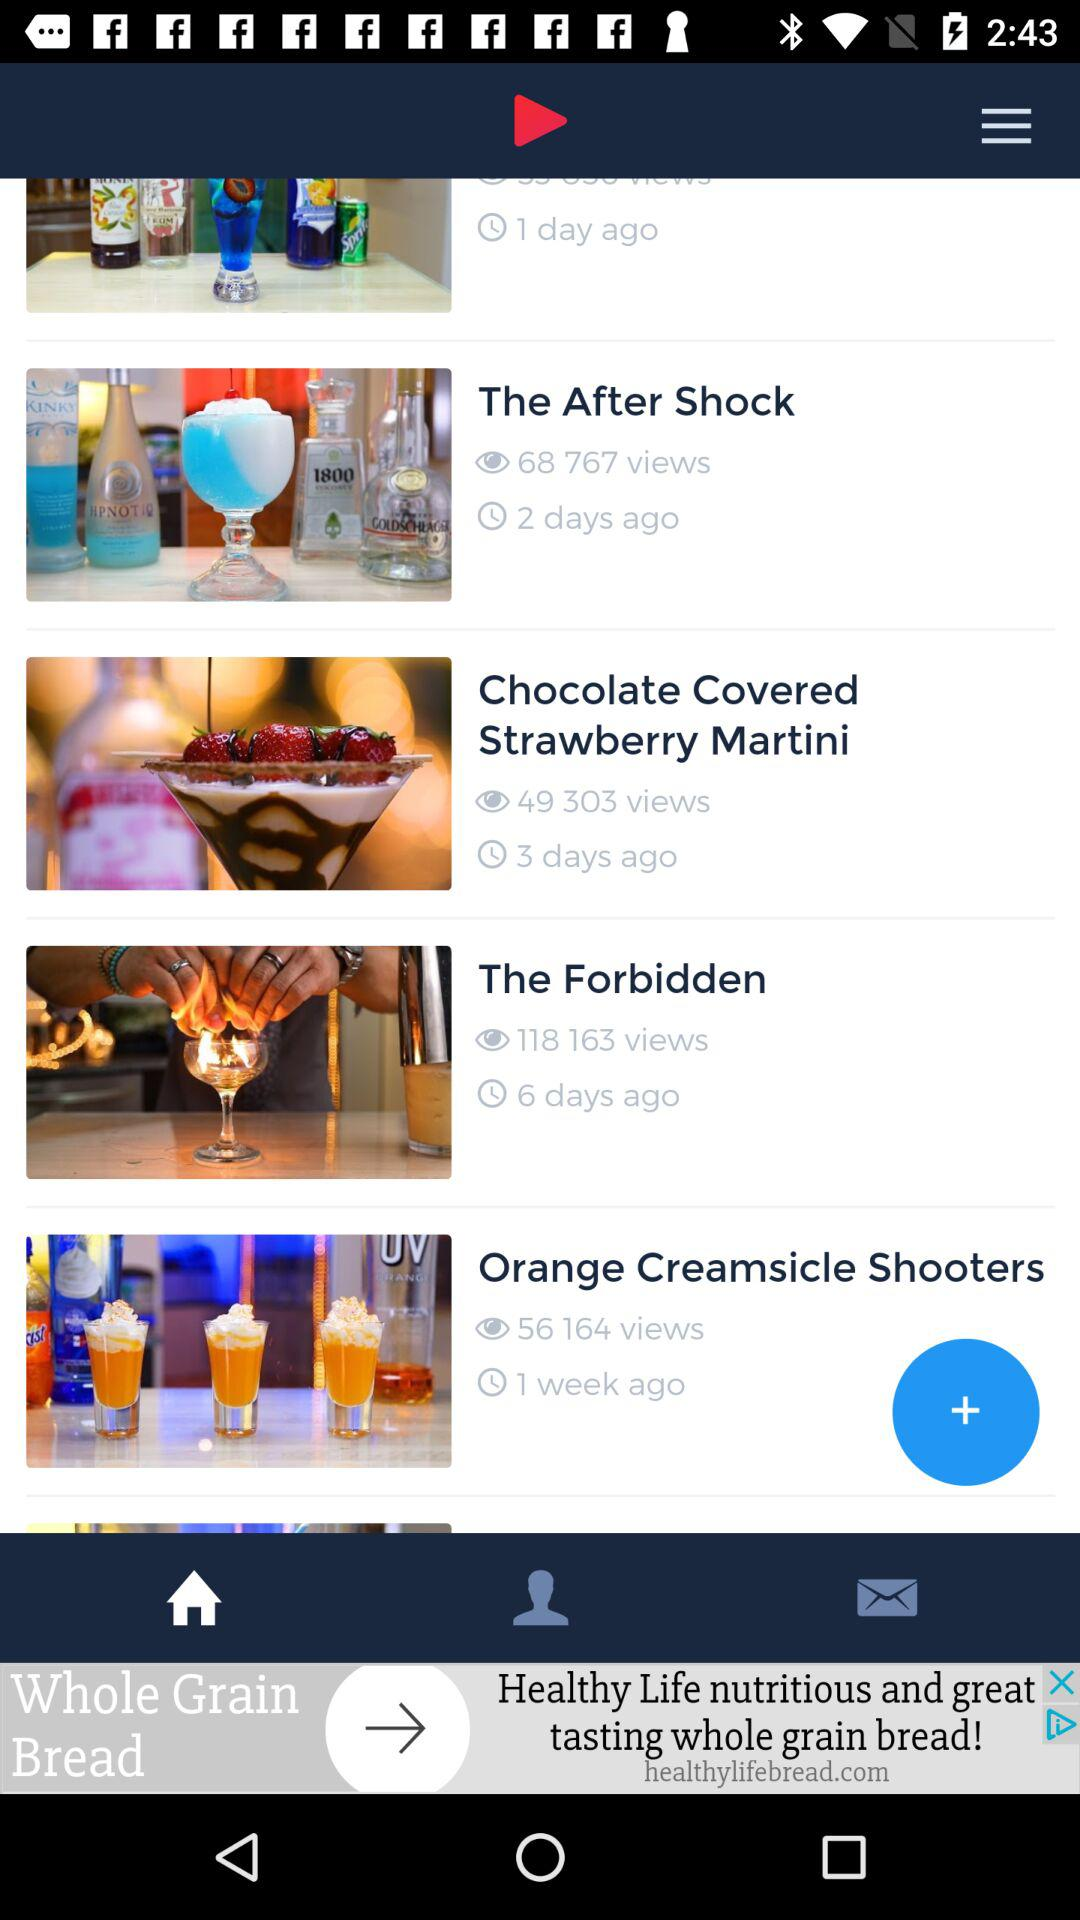How many views did the video "The After Shock" get? The video "The After Shock" got 68767 views. 